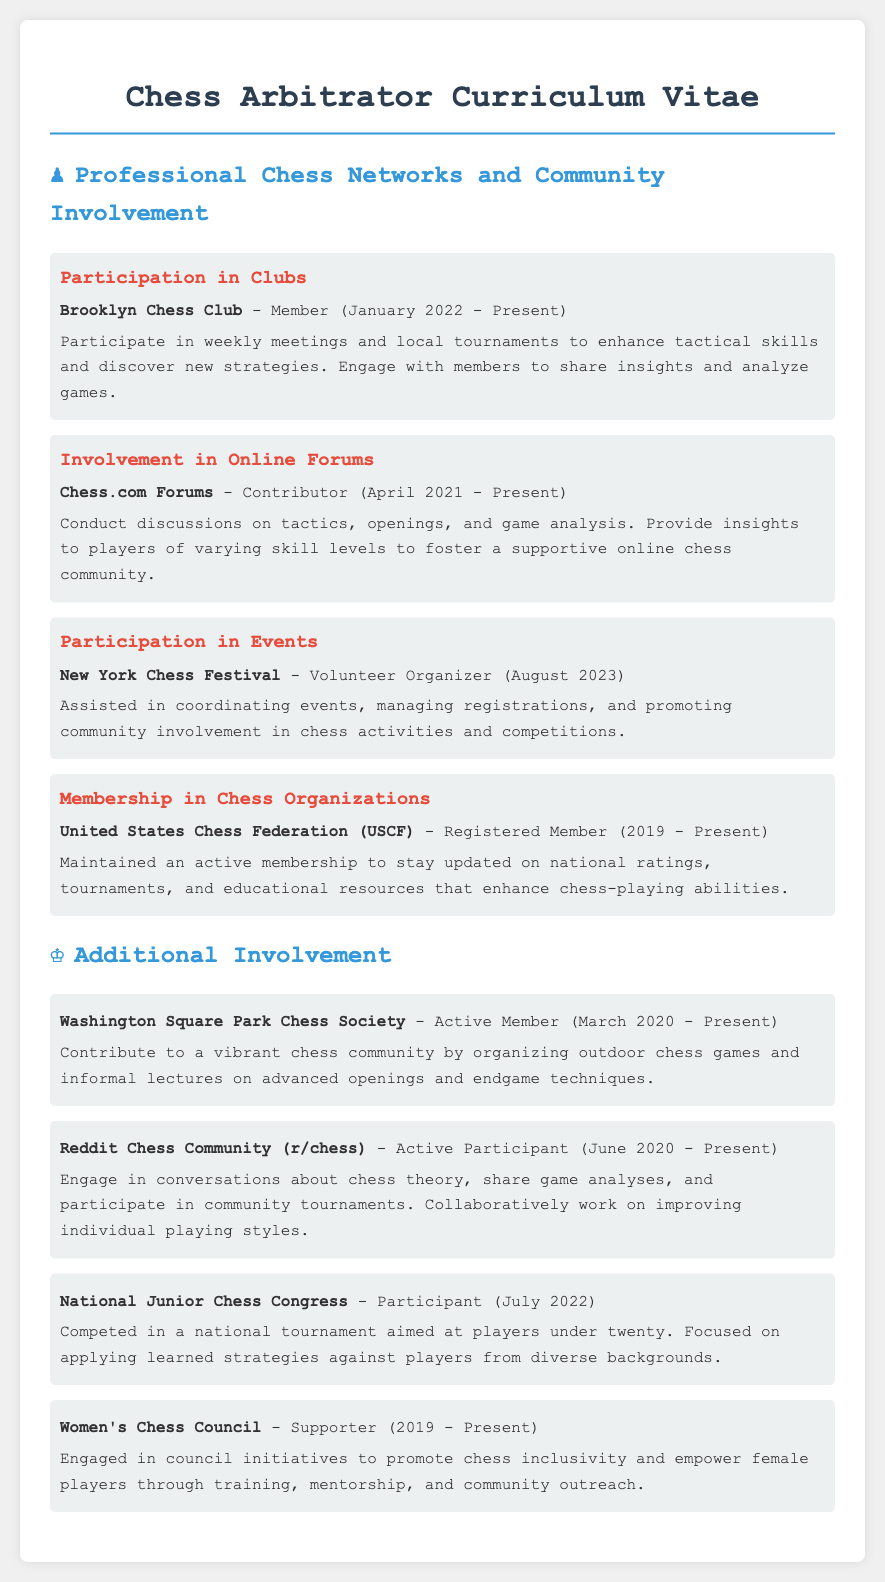What is the name of the chess club mentioned? The document lists "Brooklyn Chess Club" as a participating chess club.
Answer: Brooklyn Chess Club When did the individual become a member of the United States Chess Federation? The document states that the individual has been a registered member since 2019.
Answer: 2019 What role did the individual have at the New York Chess Festival? The document describes the individual's role as a "Volunteer Organizer" at the festival.
Answer: Volunteer Organizer How many online forums does the individual participate in? The document mentions participation in two online platforms: Chess.com Forums and Reddit Chess Community.
Answer: Two What community initiative is supported by the individual? The document indicates that the individual supports initiatives aimed at promoting inclusivity for female players.
Answer: Women's Chess Council 